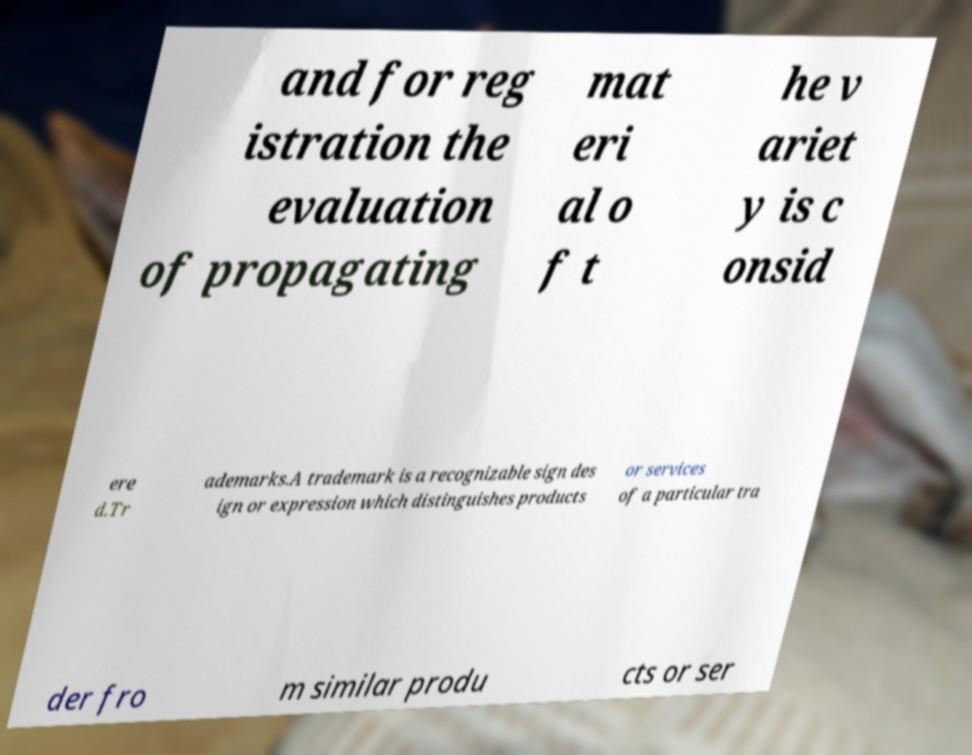Please identify and transcribe the text found in this image. and for reg istration the evaluation of propagating mat eri al o f t he v ariet y is c onsid ere d.Tr ademarks.A trademark is a recognizable sign des ign or expression which distinguishes products or services of a particular tra der fro m similar produ cts or ser 